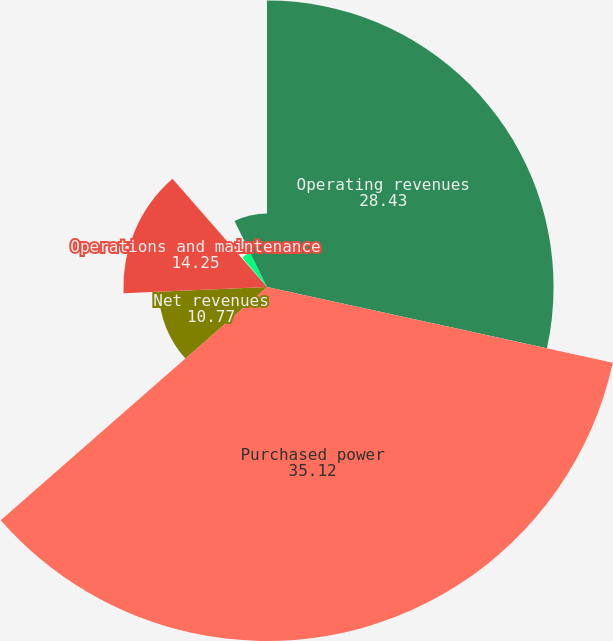Convert chart. <chart><loc_0><loc_0><loc_500><loc_500><pie_chart><fcel>Operating revenues<fcel>Purchased power<fcel>Net revenues<fcel>Operations and maintenance<fcel>Depreciation and amortization<fcel>Taxes other than income taxes<fcel>Electric operating income<nl><fcel>28.43%<fcel>35.12%<fcel>10.77%<fcel>14.25%<fcel>0.33%<fcel>3.81%<fcel>7.29%<nl></chart> 